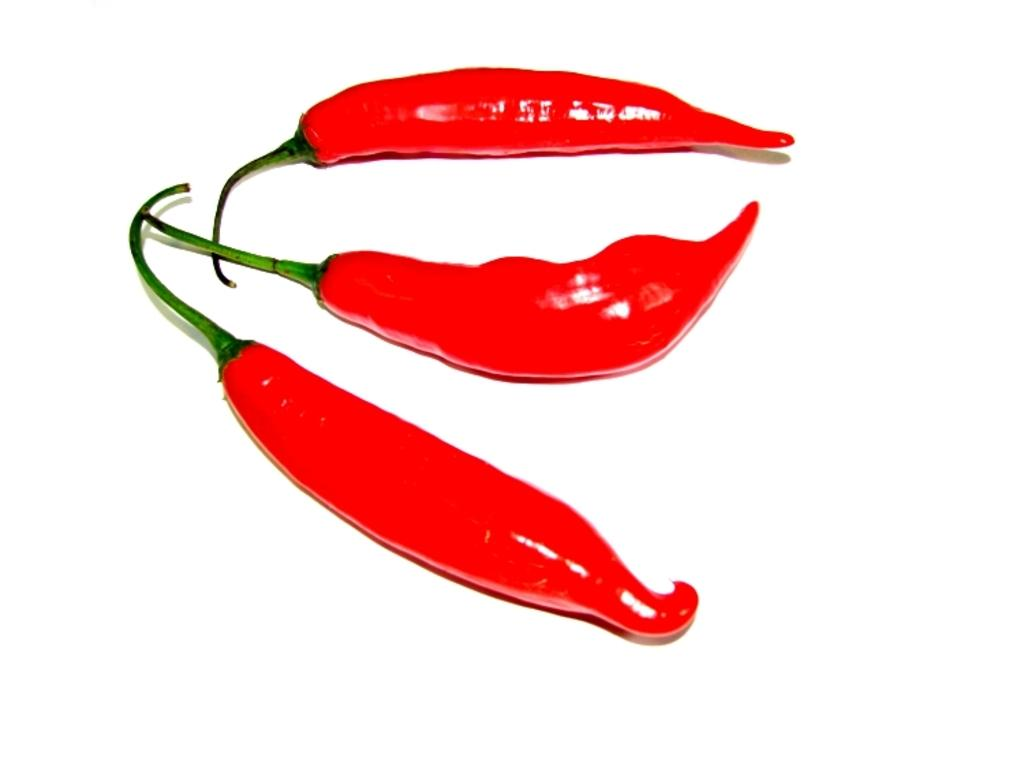What type of food is featured in the image? There are red chilies in the image. What color is the background of the image? The background of the image is white. What is the purpose of the train in the image? There is no train present in the image; it only features red chilies and a white background. How does the person push the chilies in the image? There is no person present in the image, and the chilies are stationary. 